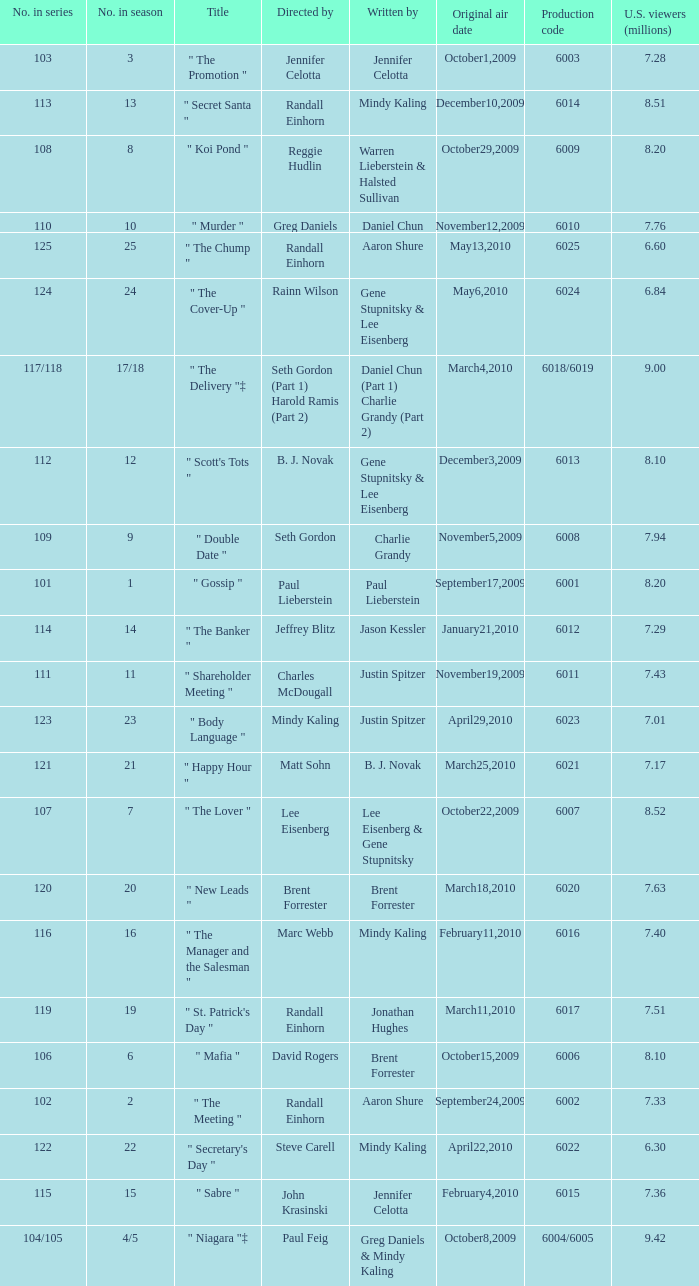Name the production code for number in season being 21 6021.0. 